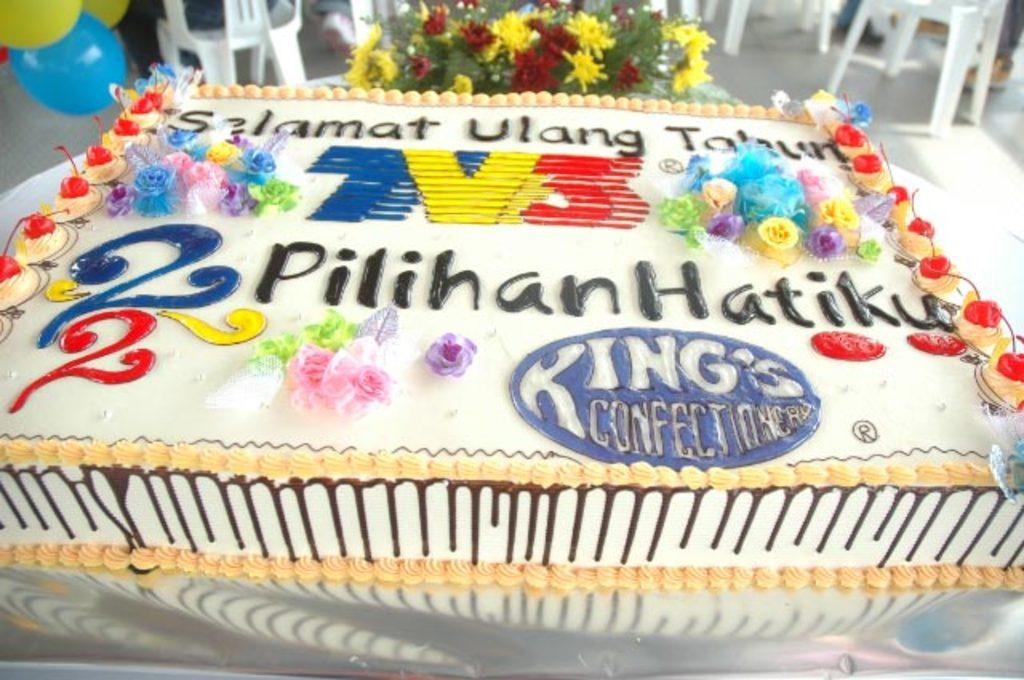What is on the table in the image? There is a cake on a table in the image. What is covering the table? The table has a white cloth covering it. What is written or depicted on the cake? There is text on the cake. What can be seen on the top of the image? There are chairs, balloons, and flowers on the top of the image. What type of zinc is present in the image? There is no zinc present in the image. What kind of machine is being used to create the cake? There is no machine visible in the image, and the cake is already prepared. 